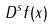<formula> <loc_0><loc_0><loc_500><loc_500>D ^ { s } f ( x )</formula> 